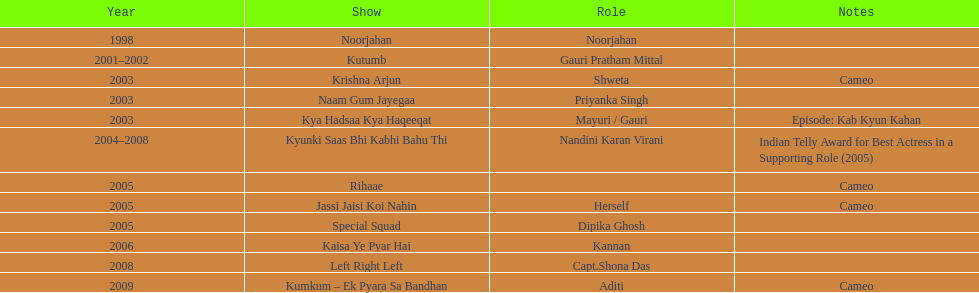Which one television program featured gauri playing her own character? Jassi Jaisi Koi Nahin. Write the full table. {'header': ['Year', 'Show', 'Role', 'Notes'], 'rows': [['1998', 'Noorjahan', 'Noorjahan', ''], ['2001–2002', 'Kutumb', 'Gauri Pratham Mittal', ''], ['2003', 'Krishna Arjun', 'Shweta', 'Cameo'], ['2003', 'Naam Gum Jayegaa', 'Priyanka Singh', ''], ['2003', 'Kya Hadsaa Kya Haqeeqat', 'Mayuri / Gauri', 'Episode: Kab Kyun Kahan'], ['2004–2008', 'Kyunki Saas Bhi Kabhi Bahu Thi', 'Nandini Karan Virani', 'Indian Telly Award for Best Actress in a Supporting Role (2005)'], ['2005', 'Rihaae', '', 'Cameo'], ['2005', 'Jassi Jaisi Koi Nahin', 'Herself', 'Cameo'], ['2005', 'Special Squad', 'Dipika Ghosh', ''], ['2006', 'Kaisa Ye Pyar Hai', 'Kannan', ''], ['2008', 'Left Right Left', 'Capt.Shona Das', ''], ['2009', 'Kumkum – Ek Pyara Sa Bandhan', 'Aditi', 'Cameo']]} 